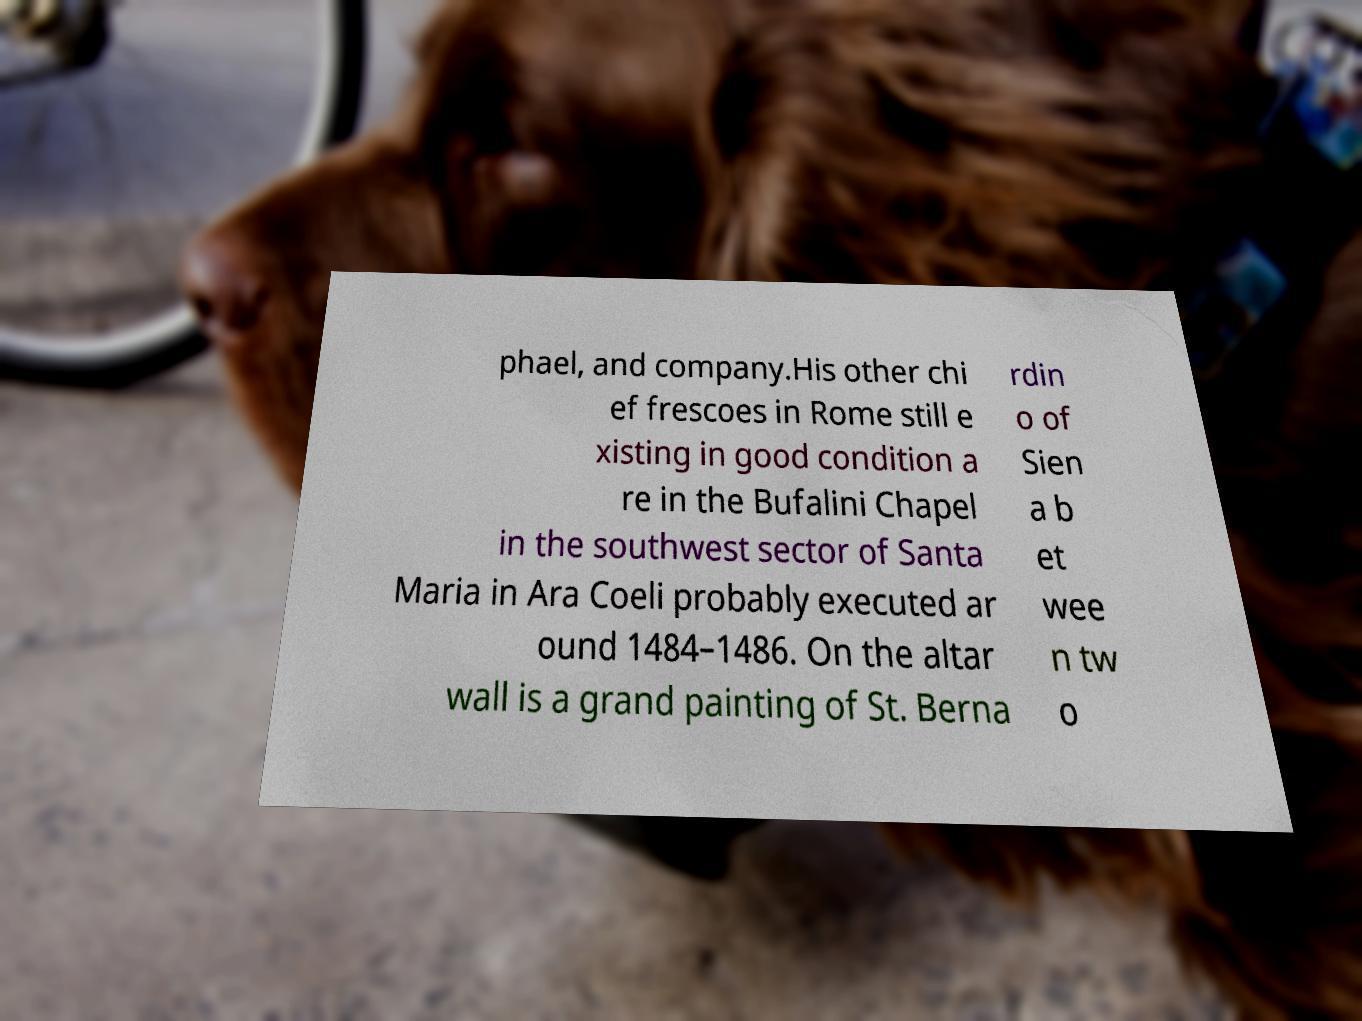Please read and relay the text visible in this image. What does it say? phael, and company.His other chi ef frescoes in Rome still e xisting in good condition a re in the Bufalini Chapel in the southwest sector of Santa Maria in Ara Coeli probably executed ar ound 1484–1486. On the altar wall is a grand painting of St. Berna rdin o of Sien a b et wee n tw o 